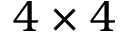Convert formula to latex. <formula><loc_0><loc_0><loc_500><loc_500>4 \times 4</formula> 